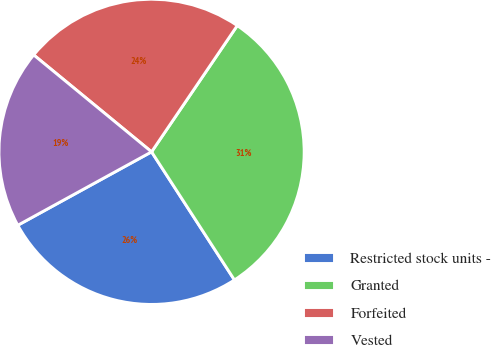<chart> <loc_0><loc_0><loc_500><loc_500><pie_chart><fcel>Restricted stock units -<fcel>Granted<fcel>Forfeited<fcel>Vested<nl><fcel>26.15%<fcel>31.37%<fcel>23.54%<fcel>18.94%<nl></chart> 